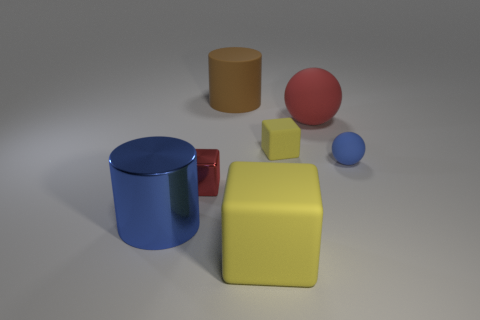Is the tiny blue thing made of the same material as the big cylinder that is right of the tiny shiny object?
Your answer should be compact. Yes. Is the shape of the large yellow rubber object the same as the large brown object?
Offer a terse response. No. What material is the tiny red object that is the same shape as the large yellow object?
Provide a short and direct response. Metal. What is the color of the big thing that is both in front of the big red sphere and behind the large yellow matte cube?
Provide a short and direct response. Blue. What is the color of the metallic cube?
Make the answer very short. Red. What is the material of the tiny thing that is the same color as the big shiny cylinder?
Give a very brief answer. Rubber. Are there any tiny blue metallic objects of the same shape as the large yellow rubber thing?
Offer a very short reply. No. What size is the yellow block that is in front of the tiny blue ball?
Your response must be concise. Large. There is a red ball that is the same size as the shiny cylinder; what is it made of?
Ensure brevity in your answer.  Rubber. Is the number of blue cylinders greater than the number of small purple metal things?
Your answer should be compact. Yes. 